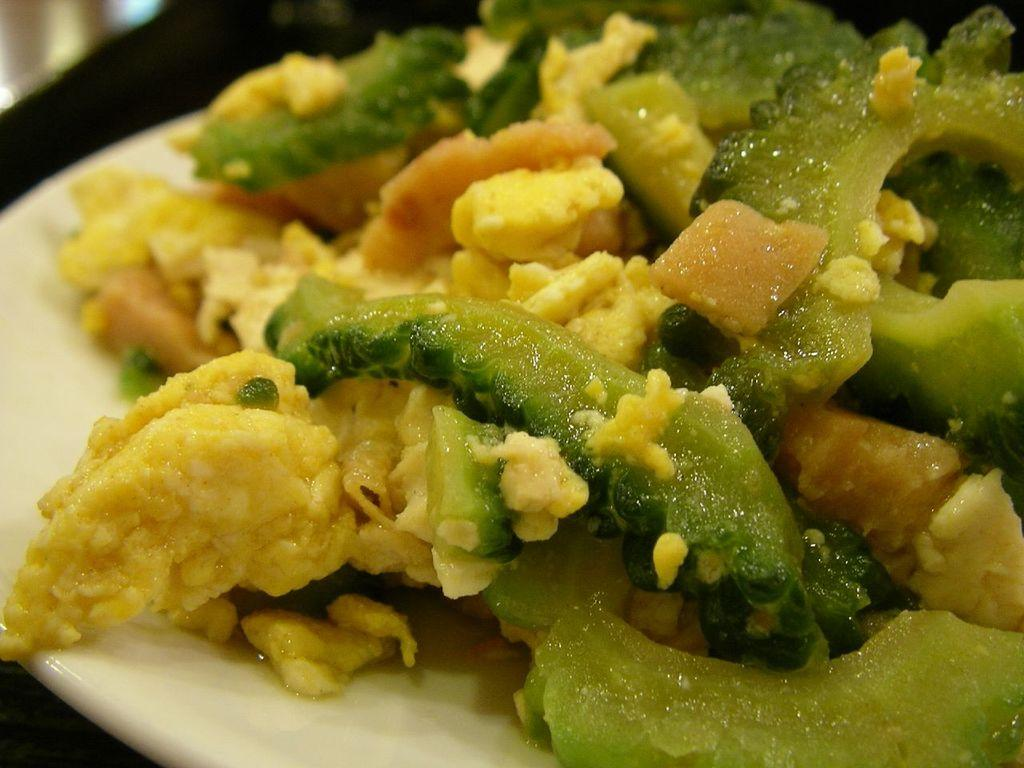What is present on the plate in the image? There is food on the plate in the image. Where is the plate with food located? The plate with food is on a table in the background of the image. What type of horn can be seen in the image? There is no horn present in the image. How many kittens are sitting on the plate with food? There are no kittens present in the image; it only features food on a plate. 